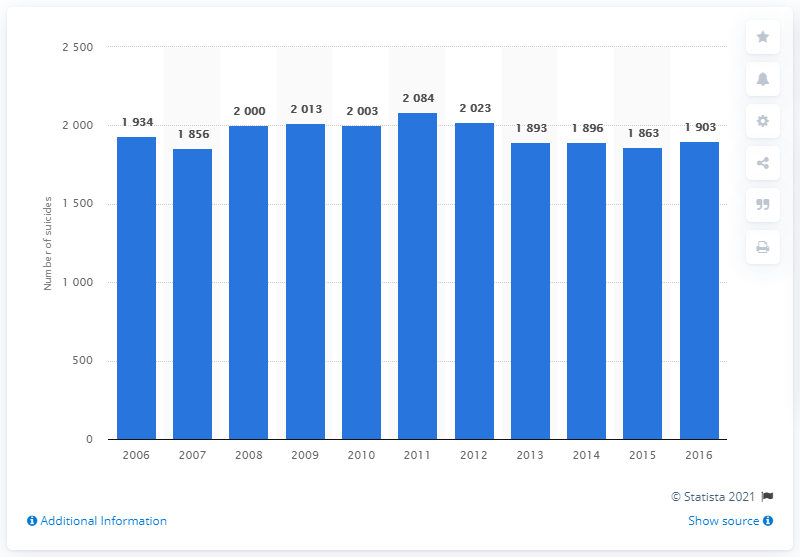Identify some key points in this picture. From 2006 to 2016, the number of suicides fluctuated significantly. In 2016, Belgium was one of the top five European countries in terms of the number of suicide casualties. 